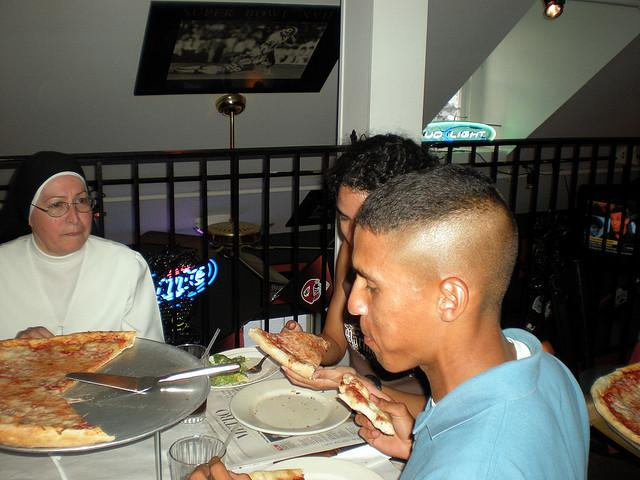What is this woman's profession?

Choices:
A) waitress
B) nun
C) clown
D) janitor nun 